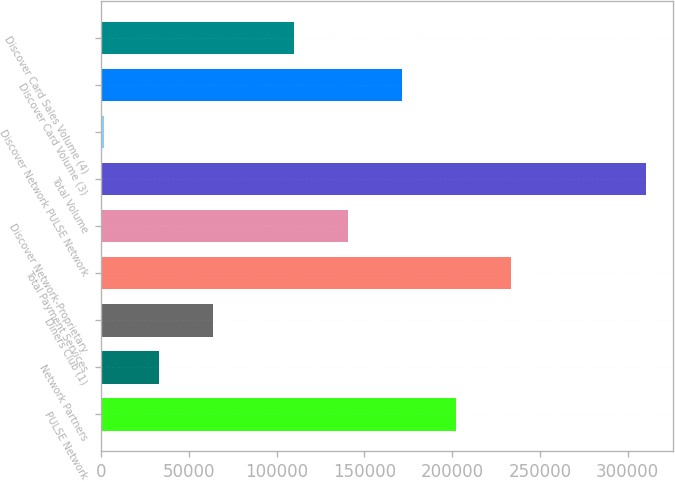Convert chart to OTSL. <chart><loc_0><loc_0><loc_500><loc_500><bar_chart><fcel>PULSE Network<fcel>Network Partners<fcel>Diners Club (1)<fcel>Total Payment Services<fcel>Discover Network-Proprietary<fcel>Total Volume<fcel>Discover Network PULSE Network<fcel>Discover Card Volume (3)<fcel>Discover Card Sales Volume (4)<nl><fcel>202454<fcel>32779.4<fcel>63611.8<fcel>233287<fcel>140789<fcel>310271<fcel>1947<fcel>171622<fcel>109957<nl></chart> 